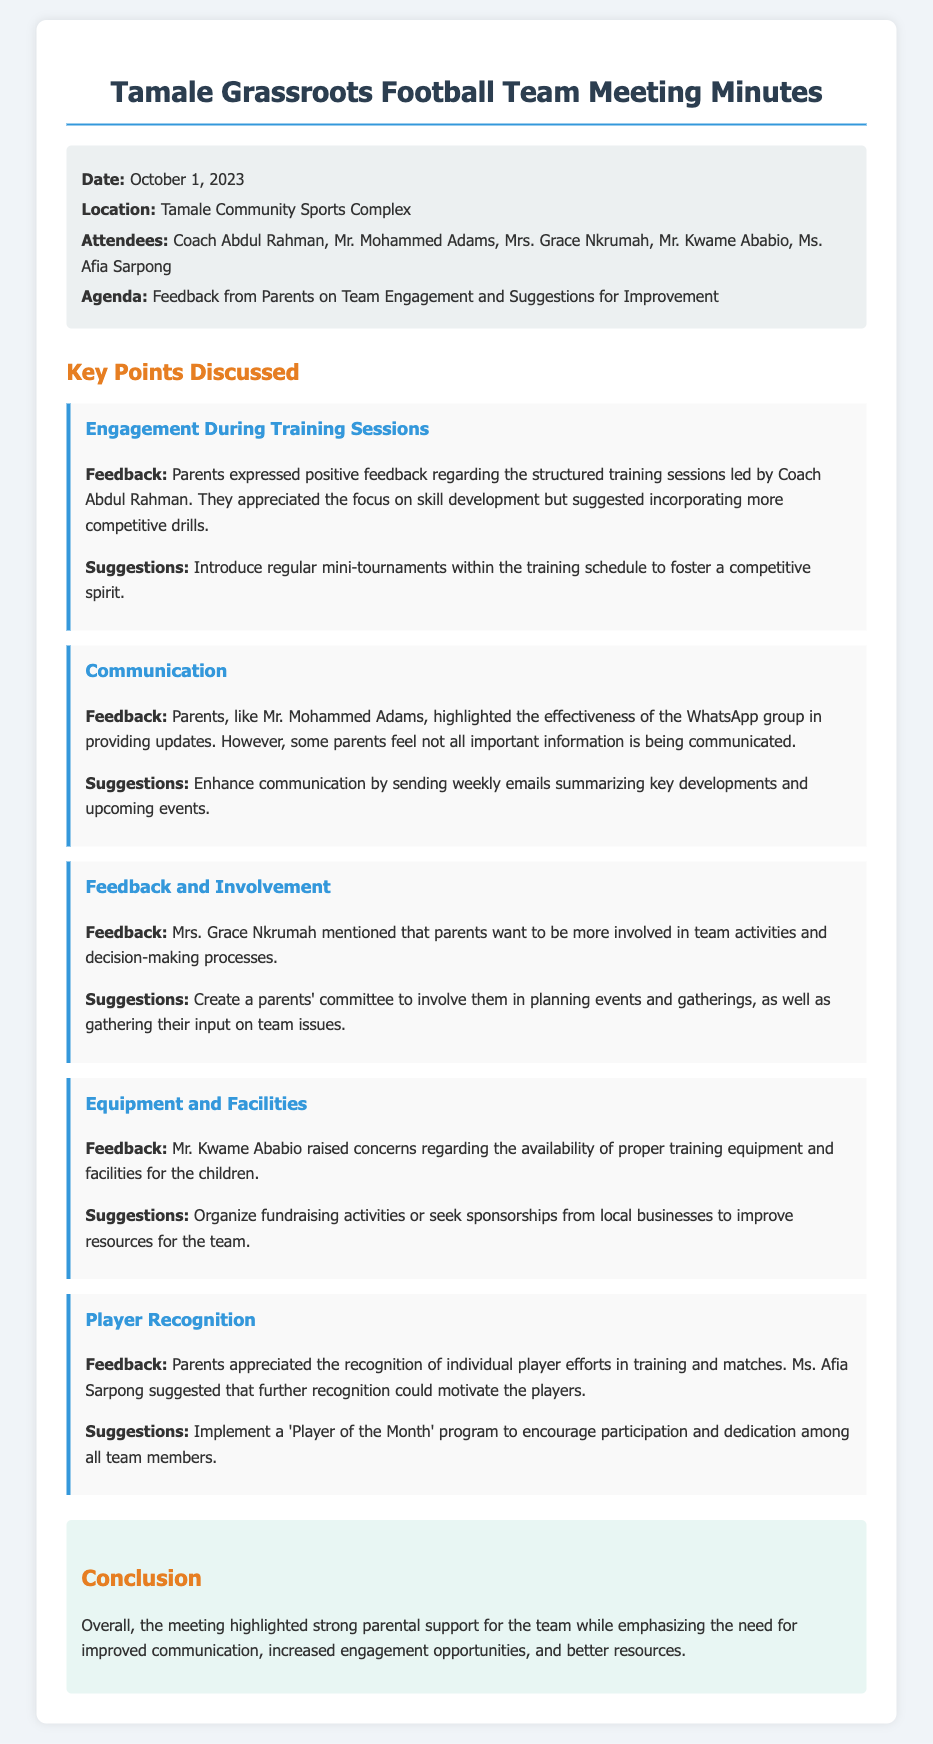What date was the meeting held? The date of the meeting is explicitly stated in the document as October 1, 2023.
Answer: October 1, 2023 Who led the training sessions? Coach Abdul Rahman is mentioned as leading the structured training sessions in the feedback from parents.
Answer: Coach Abdul Rahman What did parents appreciate about the training sessions? Parents expressed positive feedback regarding the structured training sessions specifically focused on skill development.
Answer: Skill development Who raised concerns regarding training equipment? Mr. Kwame Ababio is specifically mentioned as raising concerns about the availability of proper training equipment.
Answer: Mr. Kwame Ababio What suggestion was made to enhance communication? It was suggested to enhance communication by sending weekly emails summarizing key developments and upcoming events.
Answer: Weekly emails What program was suggested to motivate players? Ms. Afia Sarpong suggested implementing a 'Player of the Month' program to encourage participation among team members.
Answer: Player of the Month How did parents feel about their involvement in team activities? Mrs. Grace Nkrumah mentioned that parents want to be more involved in team activities and decision-making processes.
Answer: More involved What is the main conclusion from the meeting? The conclusion highlights strong parental support while emphasizing the need for improved communication and increased engagement opportunities.
Answer: Strong parental support 